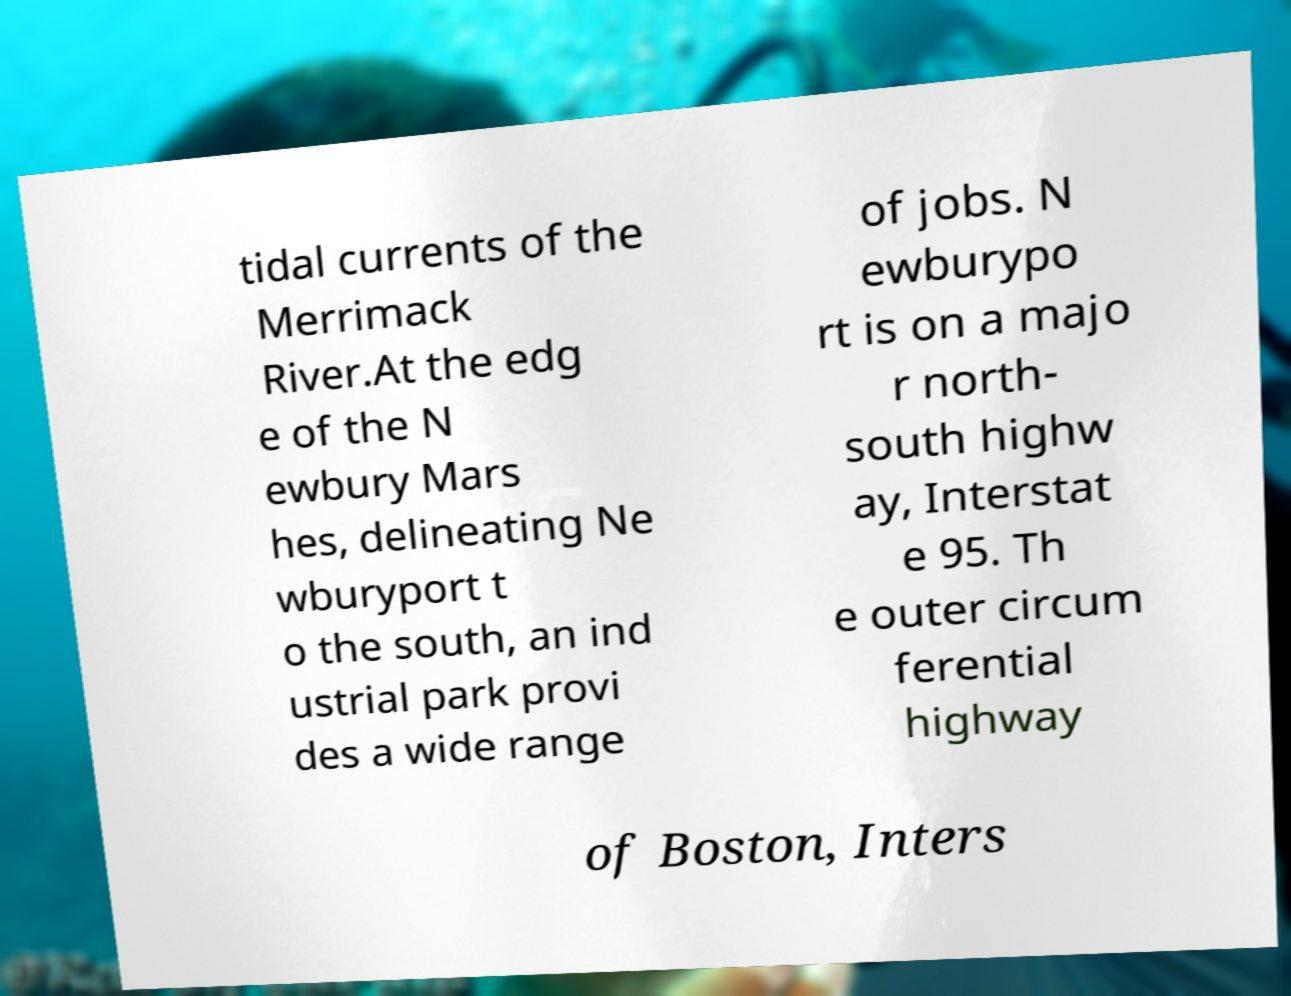Please read and relay the text visible in this image. What does it say? tidal currents of the Merrimack River.At the edg e of the N ewbury Mars hes, delineating Ne wburyport t o the south, an ind ustrial park provi des a wide range of jobs. N ewburypo rt is on a majo r north- south highw ay, Interstat e 95. Th e outer circum ferential highway of Boston, Inters 